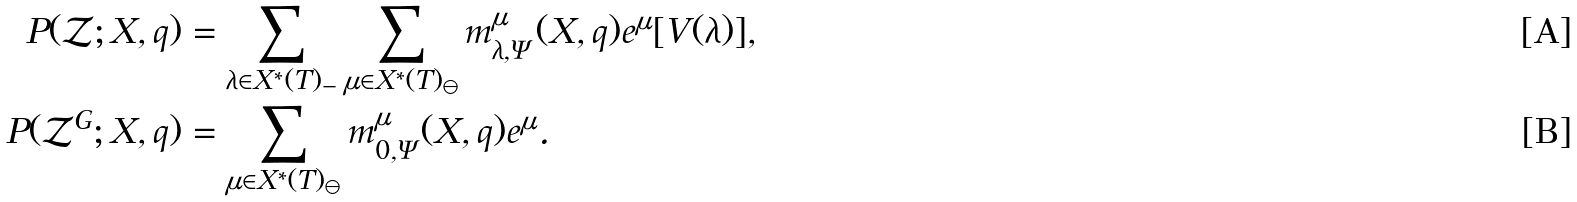<formula> <loc_0><loc_0><loc_500><loc_500>P ( \mathcal { Z } ; X , q ) & = \sum _ { \lambda \in X ^ { * } ( T ) _ { - } } \sum _ { \mu \in X ^ { * } ( T ) _ { \ominus } } m ^ { \mu } _ { \lambda , \Psi } ( X , q ) e ^ { \mu } [ V ( \lambda ) ] , \\ P ( \mathcal { Z } ^ { G } ; X , q ) & = \sum _ { \mu \in X ^ { * } ( T ) _ { \ominus } } m ^ { \mu } _ { 0 , \Psi } ( X , q ) e ^ { \mu } .</formula> 